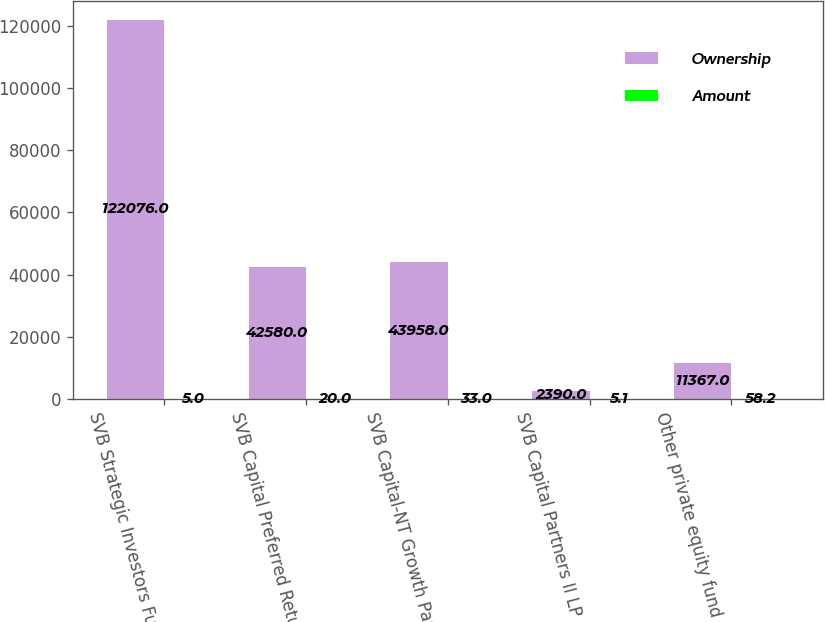Convert chart to OTSL. <chart><loc_0><loc_0><loc_500><loc_500><stacked_bar_chart><ecel><fcel>SVB Strategic Investors Fund<fcel>SVB Capital Preferred Return<fcel>SVB Capital-NT Growth Partners<fcel>SVB Capital Partners II LP (i)<fcel>Other private equity fund (ii)<nl><fcel>Ownership<fcel>122076<fcel>42580<fcel>43958<fcel>2390<fcel>11367<nl><fcel>Amount<fcel>5<fcel>20<fcel>33<fcel>5.1<fcel>58.2<nl></chart> 